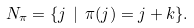Convert formula to latex. <formula><loc_0><loc_0><loc_500><loc_500>N _ { \pi } = \{ j \ | \ \pi ( j ) = j + k \} .</formula> 